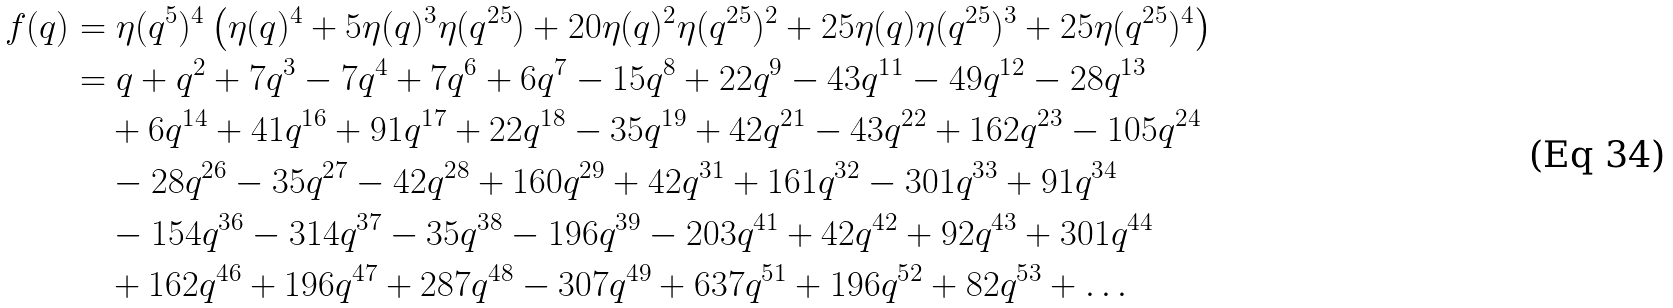<formula> <loc_0><loc_0><loc_500><loc_500>f ( q ) & = \eta ( q ^ { 5 } ) ^ { 4 } \left ( \eta ( q ) ^ { 4 } + 5 \eta ( q ) ^ { 3 } \eta ( q ^ { 2 5 } ) + 2 0 \eta ( q ) ^ { 2 } \eta ( q ^ { 2 5 } ) ^ { 2 } + 2 5 \eta ( q ) \eta ( q ^ { 2 5 } ) ^ { 3 } + 2 5 \eta ( q ^ { 2 5 } ) ^ { 4 } \right ) \\ & = q + q ^ { 2 } + 7 q ^ { 3 } - 7 q ^ { 4 } + 7 q ^ { 6 } + 6 q ^ { 7 } - 1 5 q ^ { 8 } + 2 2 q ^ { 9 } - 4 3 q ^ { 1 1 } - 4 9 q ^ { 1 2 } - 2 8 q ^ { 1 3 } \\ & \quad + 6 q ^ { 1 4 } + 4 1 q ^ { 1 6 } + 9 1 q ^ { 1 7 } + 2 2 q ^ { 1 8 } - 3 5 q ^ { 1 9 } + 4 2 q ^ { 2 1 } - 4 3 q ^ { 2 2 } + 1 6 2 q ^ { 2 3 } - 1 0 5 q ^ { 2 4 } \\ & \quad - 2 8 q ^ { 2 6 } - 3 5 q ^ { 2 7 } - 4 2 q ^ { 2 8 } + 1 6 0 q ^ { 2 9 } + 4 2 q ^ { 3 1 } + 1 6 1 q ^ { 3 2 } - 3 0 1 q ^ { 3 3 } + 9 1 q ^ { 3 4 } \\ & \quad - 1 5 4 q ^ { 3 6 } - 3 1 4 q ^ { 3 7 } - 3 5 q ^ { 3 8 } - 1 9 6 q ^ { 3 9 } - 2 0 3 q ^ { 4 1 } + 4 2 q ^ { 4 2 } + 9 2 q ^ { 4 3 } + 3 0 1 q ^ { 4 4 } \\ & \quad + 1 6 2 q ^ { 4 6 } + 1 9 6 q ^ { 4 7 } + 2 8 7 q ^ { 4 8 } - 3 0 7 q ^ { 4 9 } + 6 3 7 q ^ { 5 1 } + 1 9 6 q ^ { 5 2 } + 8 2 q ^ { 5 3 } + \dots</formula> 